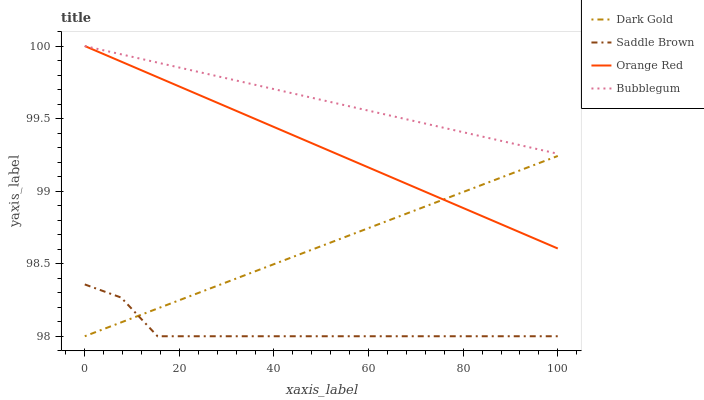Does Saddle Brown have the minimum area under the curve?
Answer yes or no. Yes. Does Bubblegum have the maximum area under the curve?
Answer yes or no. Yes. Does Orange Red have the minimum area under the curve?
Answer yes or no. No. Does Orange Red have the maximum area under the curve?
Answer yes or no. No. Is Orange Red the smoothest?
Answer yes or no. Yes. Is Saddle Brown the roughest?
Answer yes or no. Yes. Is Saddle Brown the smoothest?
Answer yes or no. No. Is Orange Red the roughest?
Answer yes or no. No. Does Saddle Brown have the lowest value?
Answer yes or no. Yes. Does Orange Red have the lowest value?
Answer yes or no. No. Does Orange Red have the highest value?
Answer yes or no. Yes. Does Saddle Brown have the highest value?
Answer yes or no. No. Is Dark Gold less than Bubblegum?
Answer yes or no. Yes. Is Orange Red greater than Saddle Brown?
Answer yes or no. Yes. Does Dark Gold intersect Saddle Brown?
Answer yes or no. Yes. Is Dark Gold less than Saddle Brown?
Answer yes or no. No. Is Dark Gold greater than Saddle Brown?
Answer yes or no. No. Does Dark Gold intersect Bubblegum?
Answer yes or no. No. 